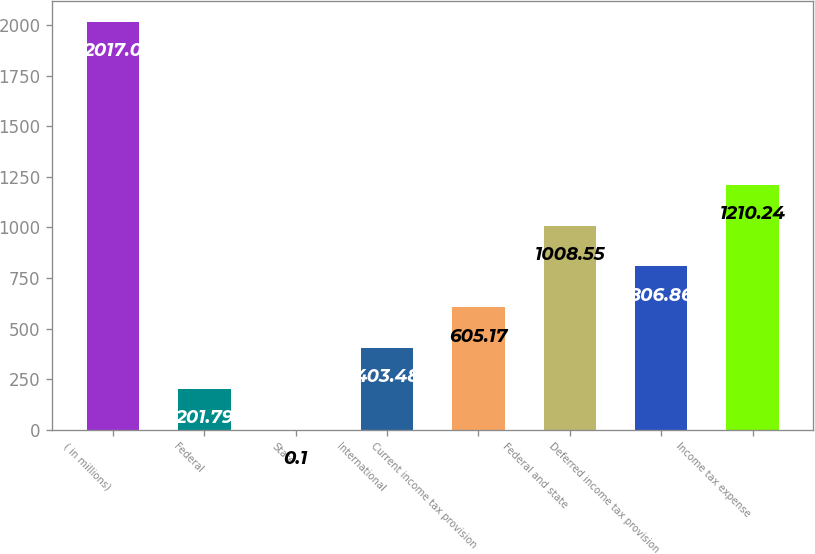Convert chart. <chart><loc_0><loc_0><loc_500><loc_500><bar_chart><fcel>( in millions)<fcel>Federal<fcel>State<fcel>International<fcel>Current income tax provision<fcel>Federal and state<fcel>Deferred income tax provision<fcel>Income tax expense<nl><fcel>2017<fcel>201.79<fcel>0.1<fcel>403.48<fcel>605.17<fcel>1008.55<fcel>806.86<fcel>1210.24<nl></chart> 